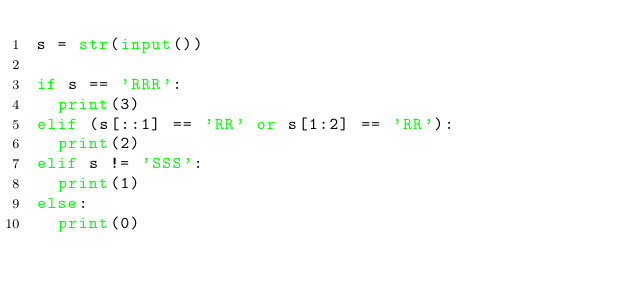<code> <loc_0><loc_0><loc_500><loc_500><_Python_>s = str(input())

if s == 'RRR':
  print(3)
elif (s[::1] == 'RR' or s[1:2] == 'RR'):
  print(2)
elif s != 'SSS':
  print(1)
else:
  print(0)</code> 